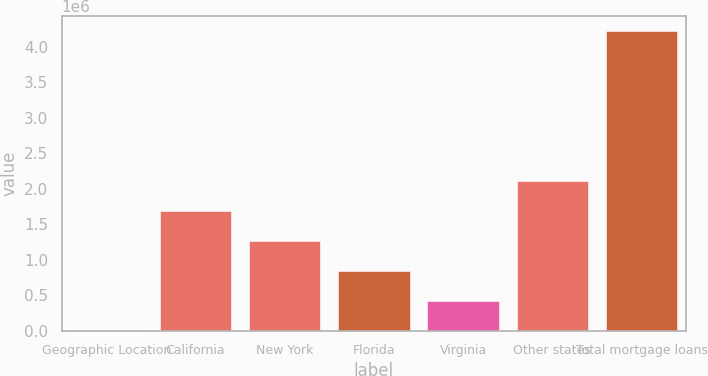Convert chart. <chart><loc_0><loc_0><loc_500><loc_500><bar_chart><fcel>Geographic Location<fcel>California<fcel>New York<fcel>Florida<fcel>Virginia<fcel>Other states<fcel>Total mortgage loans<nl><fcel>2012<fcel>1.69059e+06<fcel>1.26845e+06<fcel>846302<fcel>424157<fcel>2.11274e+06<fcel>4.22346e+06<nl></chart> 